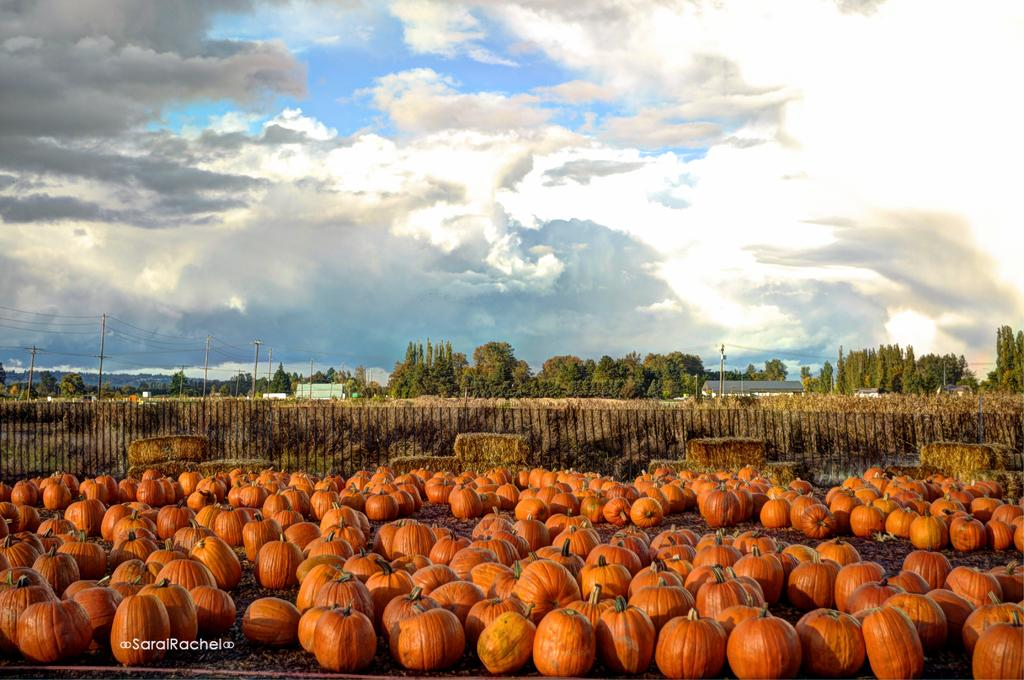What can be seen in the background of the image? In the background of the image, there is sky with clouds, trees, and current poles with transmission wires. What is present on the ground in the image? There are pumpkins on the ground in the image. What type of toys can be seen in the image? There are no toys present in the image. What rhythm is being played in the background of the image? There is no music or rhythm present in the image. 